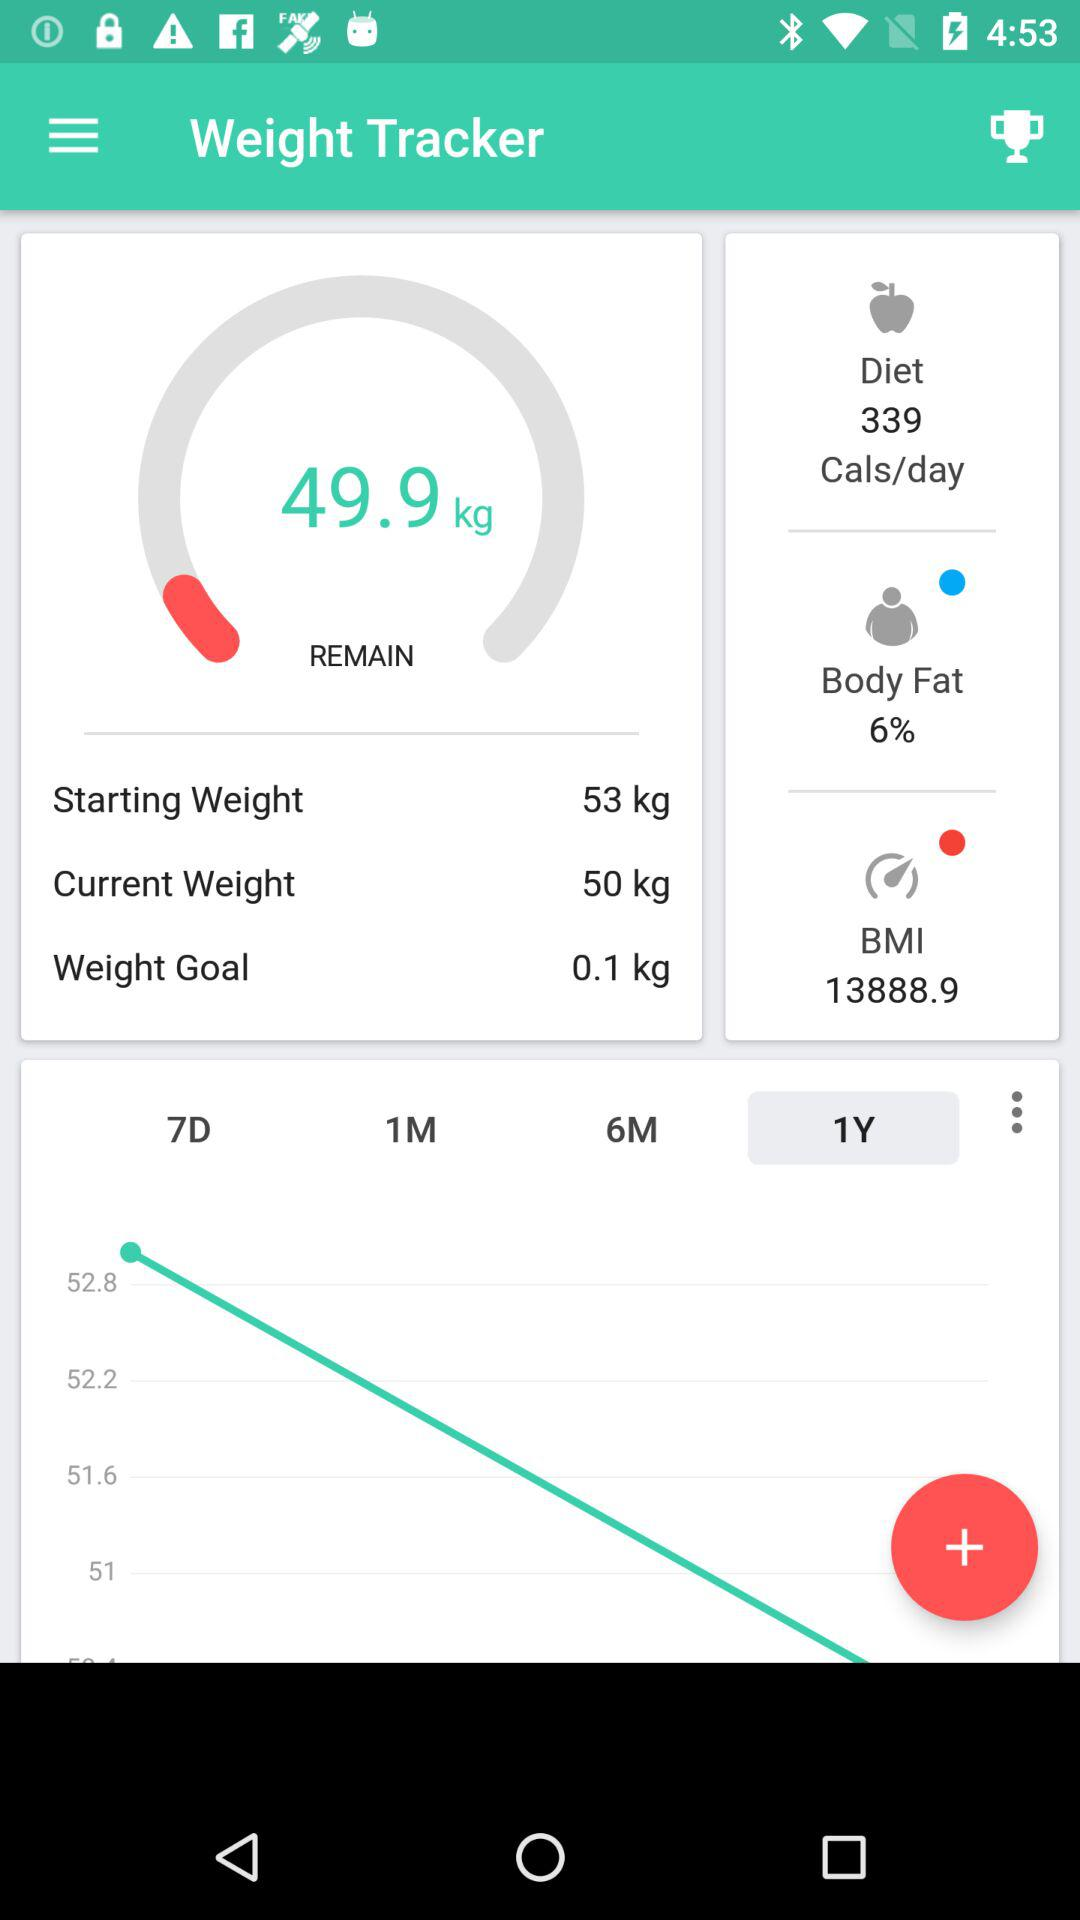What is the weight goal? The weight goal is 0.1 kg. 